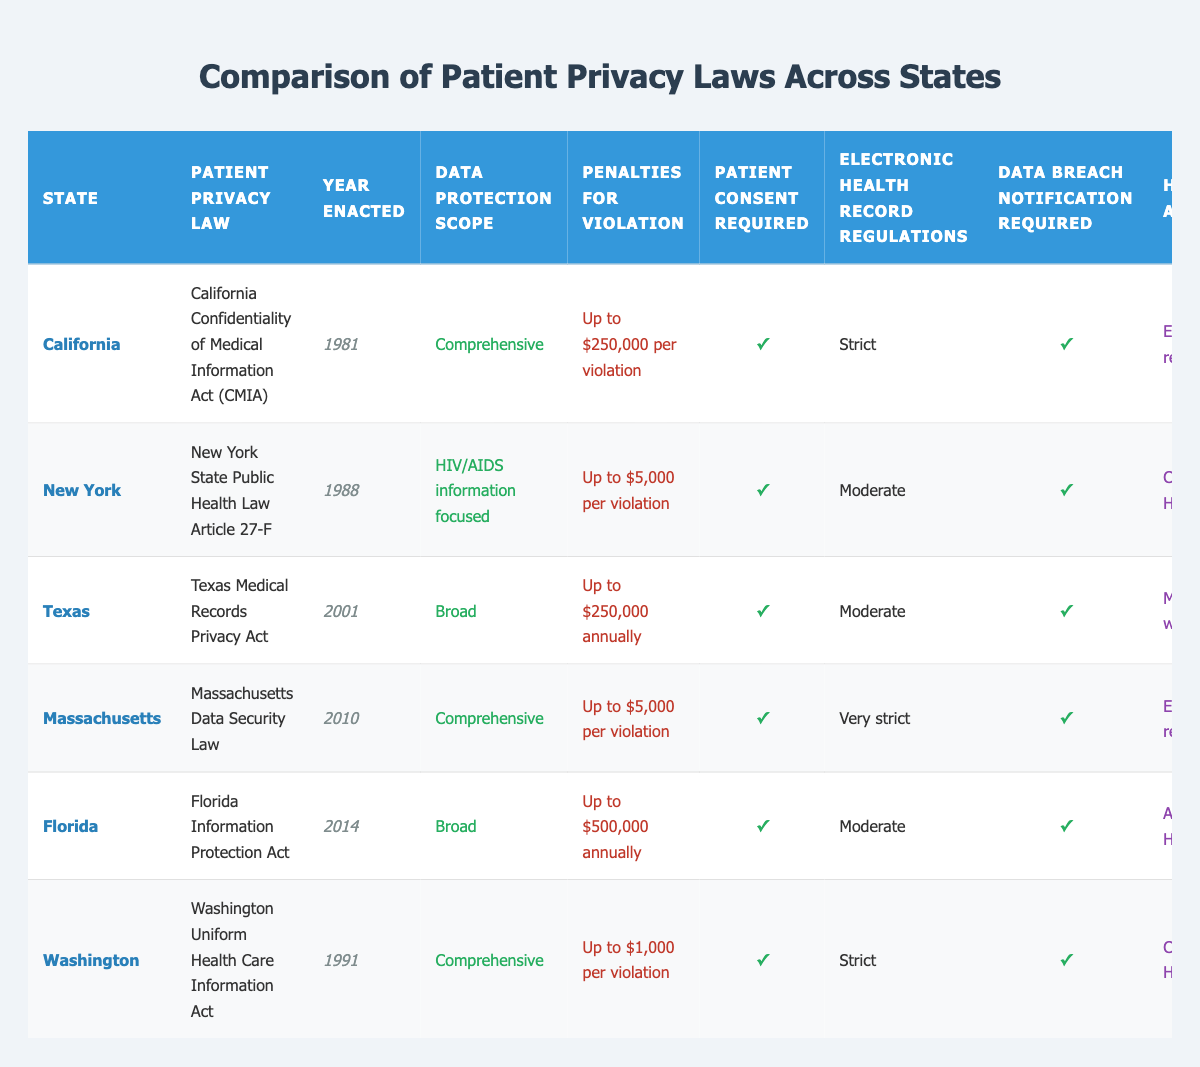What is the patient privacy law for California? According to the table, the patient privacy law for California is the California Confidentiality of Medical Information Act (CMIA). This information is directly listed under the 'Patient Privacy Law' column for California.
Answer: California Confidentiality of Medical Information Act (CMIA) Which state has the highest penalties for violation? By examining the 'Penalties for Violation' column, California and Florida have the highest penalties listed, but California specifies "up to $250,000 per violation," whereas Florida states "up to $500,000 annually." Since Florida has the higher overall cap, it is considered the state with the highest penalties for violation.
Answer: Florida Is patient consent required in New York? The table indicates a checkmark under 'Patient Consent Required' for New York, which means that patient consent is indeed required as part of its privacy law.
Answer: Yes How many states have comprehensive data protection scope? Looking at the 'Data Protection Scope' column, California, Massachusetts, and Washington are the three states that have a "Comprehensive" data protection scope. By counting these occurrences, we see there are three states.
Answer: 3 Which states have electronic health record regulations classified as strict? By checking the 'Electronic Health Record Regulations' column, California and Washington have "Strict" regulations. Therefore, those two states fit this criterion.
Answer: California, Washington What is the average penalty for violation across the states listed? The penalties for violation are: California ($250,000), New York ($5,000), Texas ($250,000 annually), Massachusetts ($5,000), Florida ($500,000 annually), and Washington ($1,000). To find the average, we consider the amounts: (250,000 + 5,000 + 250,000 + 5,000 + 500,000 + 1,000) / 6 = 835,000 / 6 = 139,166.67. The average penalty is approximately $139,167.
Answer: $139,167 Does Massachusetts exceed HIPAA requirements? The table shows that Massachusetts aligns with "Exceeds HIPAA requirements" under the 'HIPAA Alignment' column, indicating that it indeed meets this condition.
Answer: Yes Which state enacted its privacy law first, and what year was it enacted? From the 'Year Enacted' column, California's law was enacted in 1981, which is earlier than any other listed state, making it the first.
Answer: California, 1981 If a patient’s data is breached in Texas, what is the maximum annual penalty? The table specifies in the 'Penalties for Violation' column that Texas has a maximum penalty of "Up to $250,000 annually." This is the maximum penalty for breaches related to patient data in Texas.
Answer: Up to $250,000 annually 